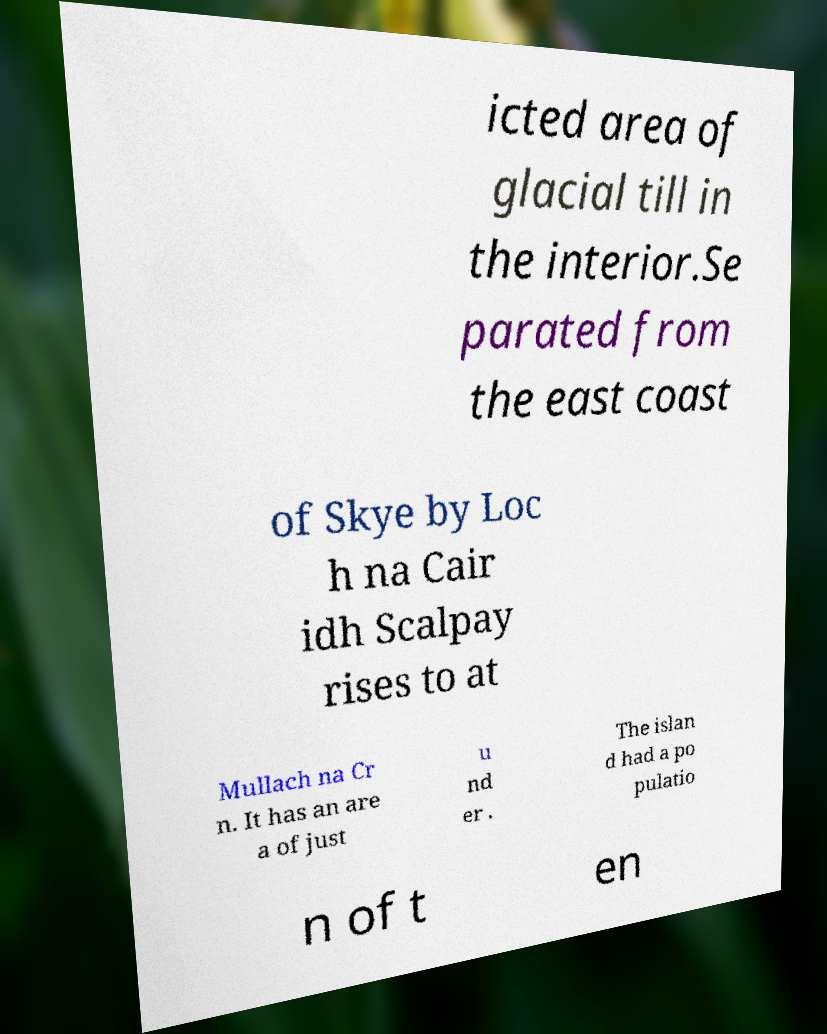Please identify and transcribe the text found in this image. icted area of glacial till in the interior.Se parated from the east coast of Skye by Loc h na Cair idh Scalpay rises to at Mullach na Cr n. It has an are a of just u nd er . The islan d had a po pulatio n of t en 